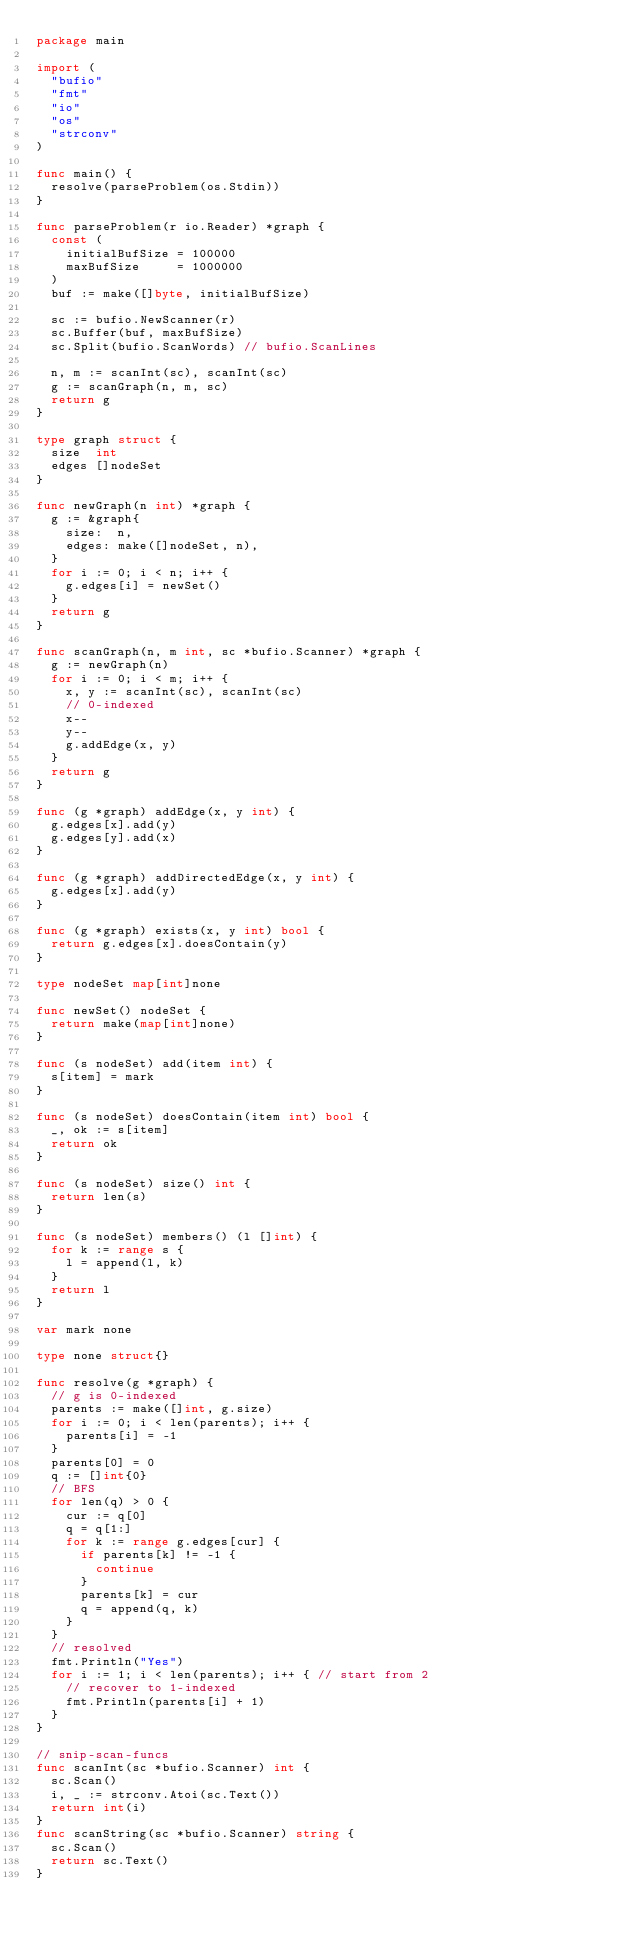Convert code to text. <code><loc_0><loc_0><loc_500><loc_500><_Go_>package main

import (
	"bufio"
	"fmt"
	"io"
	"os"
	"strconv"
)

func main() {
	resolve(parseProblem(os.Stdin))
}

func parseProblem(r io.Reader) *graph {
	const (
		initialBufSize = 100000
		maxBufSize     = 1000000
	)
	buf := make([]byte, initialBufSize)

	sc := bufio.NewScanner(r)
	sc.Buffer(buf, maxBufSize)
	sc.Split(bufio.ScanWords) // bufio.ScanLines

	n, m := scanInt(sc), scanInt(sc)
	g := scanGraph(n, m, sc)
	return g
}

type graph struct {
	size  int
	edges []nodeSet
}

func newGraph(n int) *graph {
	g := &graph{
		size:  n,
		edges: make([]nodeSet, n),
	}
	for i := 0; i < n; i++ {
		g.edges[i] = newSet()
	}
	return g
}

func scanGraph(n, m int, sc *bufio.Scanner) *graph {
	g := newGraph(n)
	for i := 0; i < m; i++ {
		x, y := scanInt(sc), scanInt(sc)
		// 0-indexed
		x--
		y--
		g.addEdge(x, y)
	}
	return g
}

func (g *graph) addEdge(x, y int) {
	g.edges[x].add(y)
	g.edges[y].add(x)
}

func (g *graph) addDirectedEdge(x, y int) {
	g.edges[x].add(y)
}

func (g *graph) exists(x, y int) bool {
	return g.edges[x].doesContain(y)
}

type nodeSet map[int]none

func newSet() nodeSet {
	return make(map[int]none)
}

func (s nodeSet) add(item int) {
	s[item] = mark
}

func (s nodeSet) doesContain(item int) bool {
	_, ok := s[item]
	return ok
}

func (s nodeSet) size() int {
	return len(s)
}

func (s nodeSet) members() (l []int) {
	for k := range s {
		l = append(l, k)
	}
	return l
}

var mark none

type none struct{}

func resolve(g *graph) {
	// g is 0-indexed
	parents := make([]int, g.size)
	for i := 0; i < len(parents); i++ {
		parents[i] = -1
	}
	parents[0] = 0
	q := []int{0}
	// BFS
	for len(q) > 0 {
		cur := q[0]
		q = q[1:]
		for k := range g.edges[cur] {
			if parents[k] != -1 {
				continue
			}
			parents[k] = cur
			q = append(q, k)
		}
	}
	// resolved
	fmt.Println("Yes")
	for i := 1; i < len(parents); i++ { // start from 2
		// recover to 1-indexed
		fmt.Println(parents[i] + 1)
	}
}

// snip-scan-funcs
func scanInt(sc *bufio.Scanner) int {
	sc.Scan()
	i, _ := strconv.Atoi(sc.Text())
	return int(i)
}
func scanString(sc *bufio.Scanner) string {
	sc.Scan()
	return sc.Text()
}
</code> 